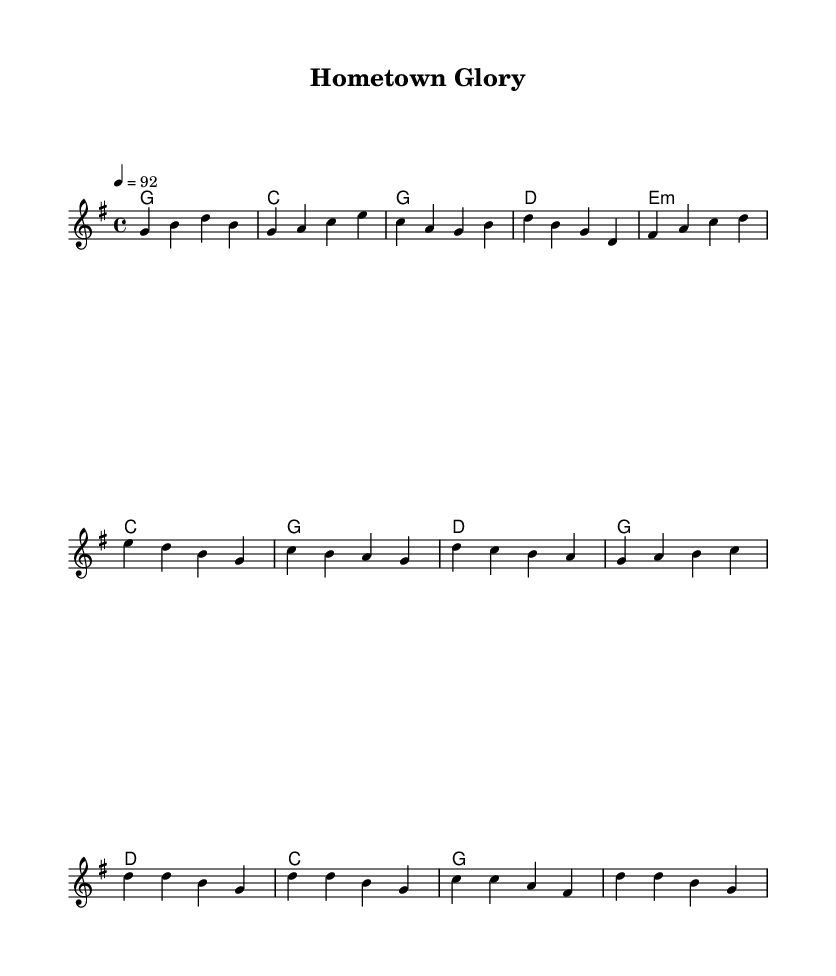What is the key signature of this music? The key signature is G major, which has one sharp (F#).
Answer: G major What is the time signature of this piece? The time signature indicated is 4/4, meaning there are four beats in each measure.
Answer: 4/4 What is the tempo marking for this piece? The tempo marking is quarter note equals 92, which indicates the speed of performance.
Answer: 92 How many measures are in the verse section? The verse is comprised of four measures, as shown by the notation before the Pre-Chorus.
Answer: 4 What is the difference between the verse harmonies and the chorus harmonies? The verse harmonies progress through G, C, G, D while the chorus harmonies transition through G, D, C, G, indicating distinct harmonic structures.
Answer: G, C, D; G, D, C Which note appears first in the pre-chorus melody? The first note of the pre-chorus melody is E, as it is the starting pitch shown in that section.
Answer: E What instrument is not explicitly mentioned but can play this sheet music? A guitar can play the chords beneath the melody, which is common in Country music.
Answer: Guitar 